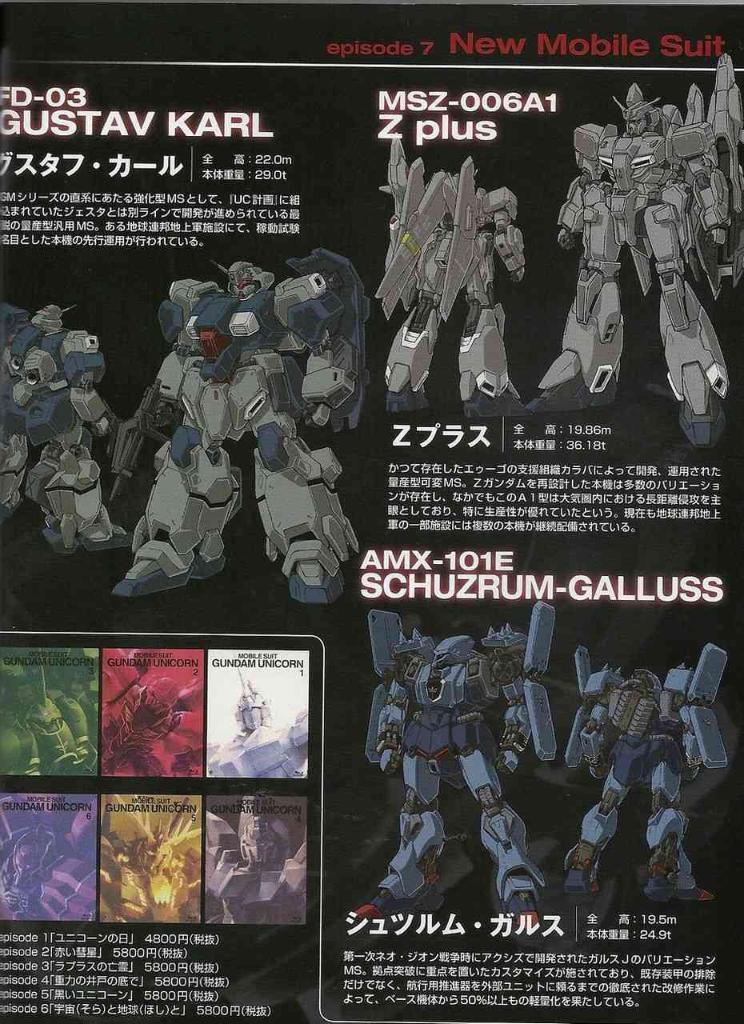What kind of suits are these?
Provide a succinct answer. Mobile. 